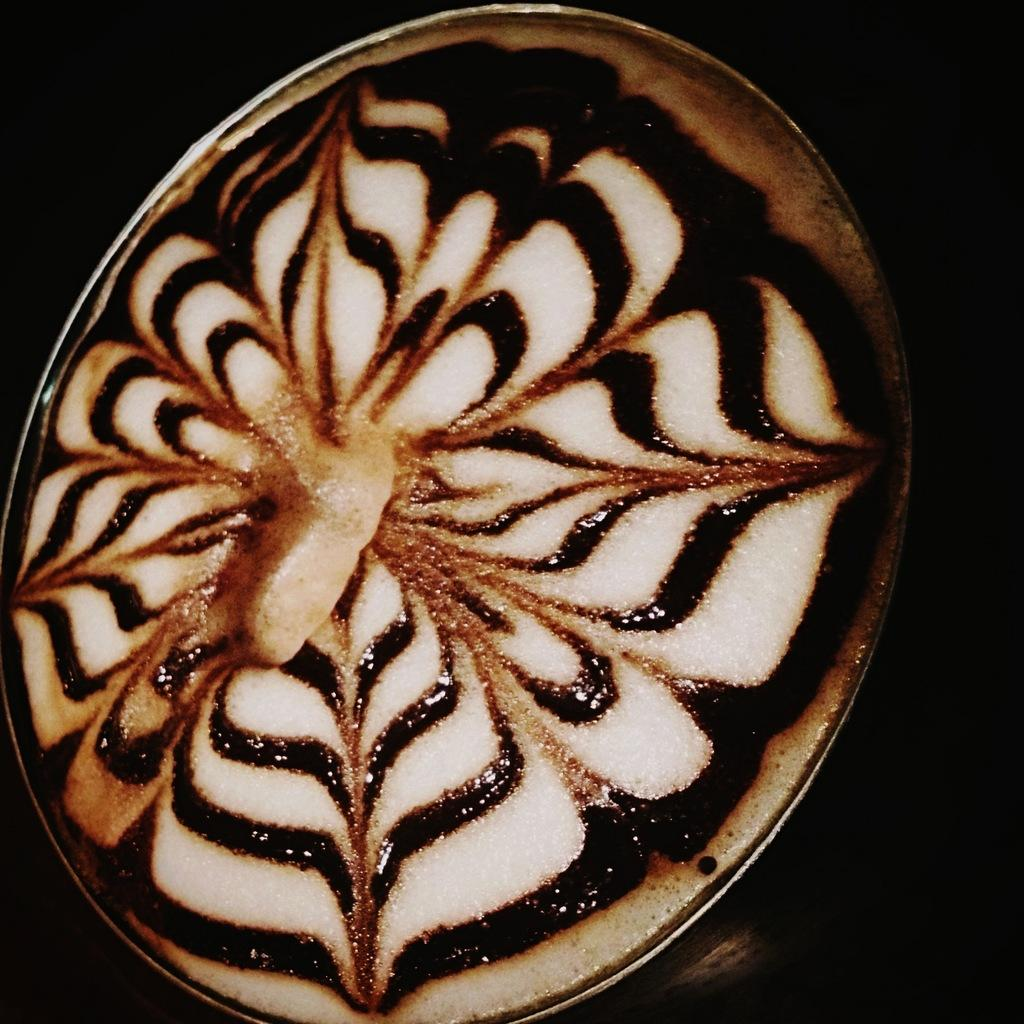What is on the plate that is visible in the image? There is cappuccino on the plate in the image. What else can be seen in the image besides the plate and cappuccino? The background of the image is black. What type of silk fabric is draped over the cappuccino in the image? There is no silk fabric present in the image; it only features a plate with cappuccino and a black background. 